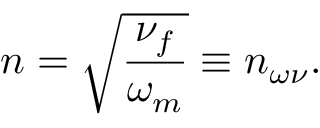Convert formula to latex. <formula><loc_0><loc_0><loc_500><loc_500>n = \sqrt { \frac { \nu _ { f } } { \omega _ { m } } } \equiv n _ { \omega \nu } .</formula> 